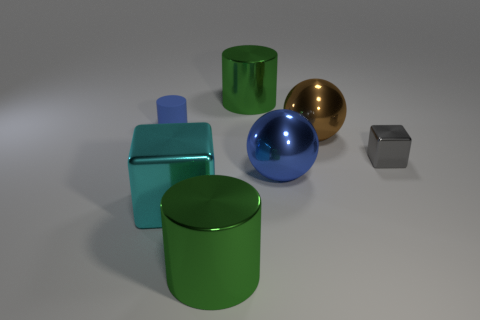There is a metal cube in front of the gray block; what color is it?
Provide a succinct answer. Cyan. Is there any other thing that has the same shape as the small gray metallic thing?
Provide a succinct answer. Yes. How big is the shiny block to the left of the cube that is behind the big cyan metallic object?
Your response must be concise. Large. Is the number of small gray objects right of the large brown object the same as the number of green things that are left of the large cyan shiny block?
Your response must be concise. No. Is there any other thing that is the same size as the cyan object?
Offer a terse response. Yes. There is a sphere that is the same material as the brown thing; what is its color?
Offer a terse response. Blue. Are the small blue cylinder and the object that is behind the tiny matte cylinder made of the same material?
Provide a short and direct response. No. There is a cylinder that is behind the brown metal ball and to the right of the large block; what is its color?
Make the answer very short. Green. What number of cylinders are large blue metallic objects or small things?
Your answer should be very brief. 1. There is a large cyan shiny thing; does it have the same shape as the large green metal thing behind the large cyan metal thing?
Provide a succinct answer. No. 